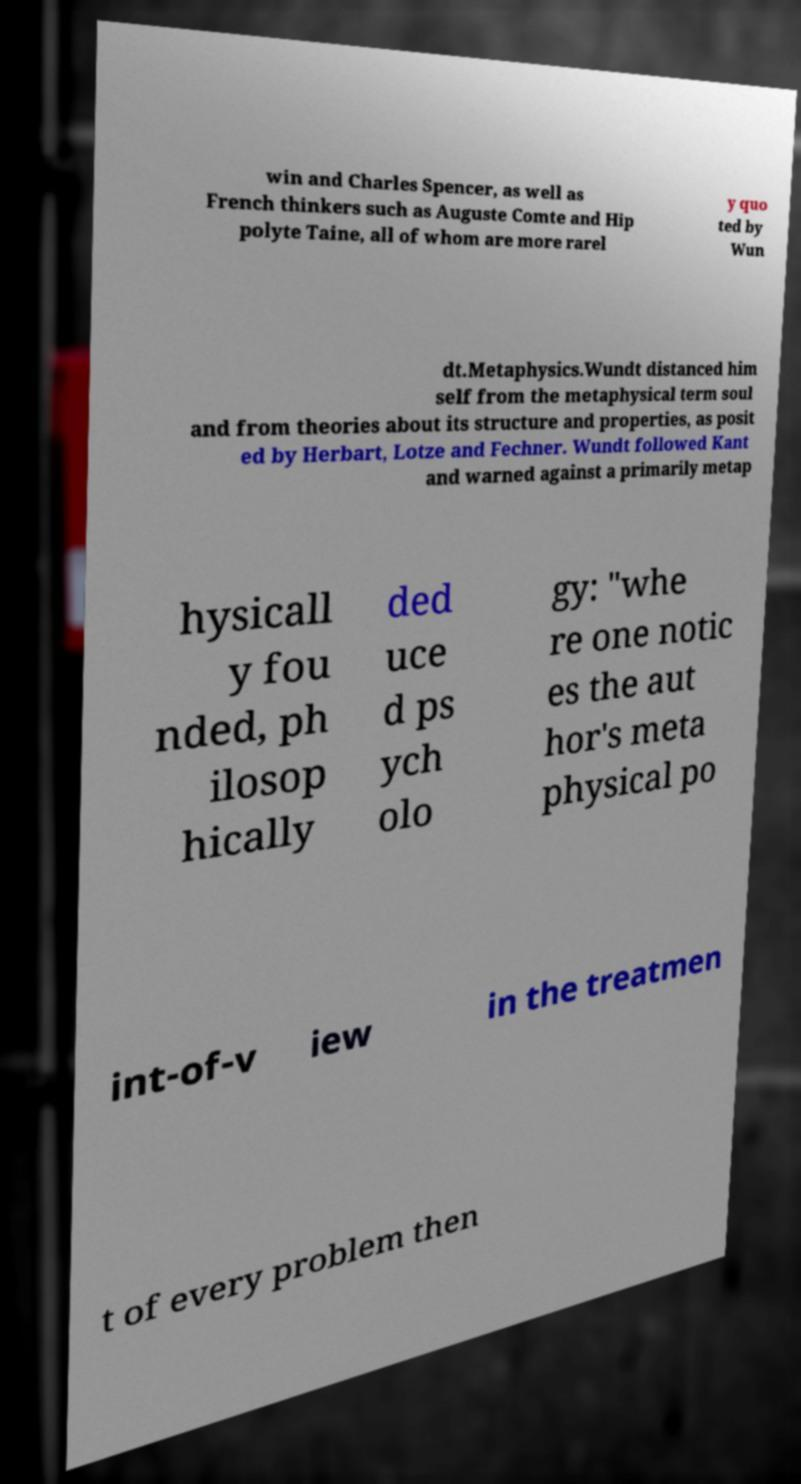Please identify and transcribe the text found in this image. win and Charles Spencer, as well as French thinkers such as Auguste Comte and Hip polyte Taine, all of whom are more rarel y quo ted by Wun dt.Metaphysics.Wundt distanced him self from the metaphysical term soul and from theories about its structure and properties, as posit ed by Herbart, Lotze and Fechner. Wundt followed Kant and warned against a primarily metap hysicall y fou nded, ph ilosop hically ded uce d ps ych olo gy: "whe re one notic es the aut hor's meta physical po int-of-v iew in the treatmen t of every problem then 